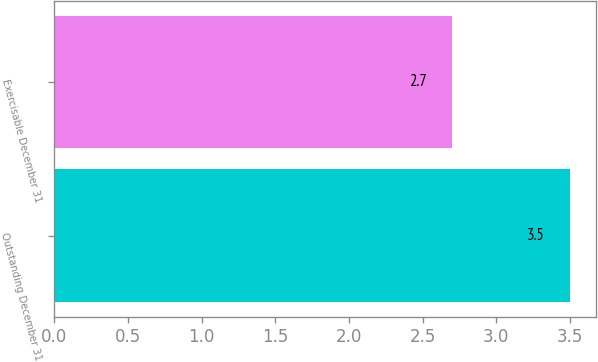<chart> <loc_0><loc_0><loc_500><loc_500><bar_chart><fcel>Outstanding December 31<fcel>Exercisable December 31<nl><fcel>3.5<fcel>2.7<nl></chart> 